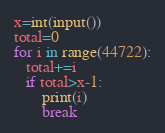<code> <loc_0><loc_0><loc_500><loc_500><_Python_>x=int(input())
total=0
for i in range(44722):
   total+=i
   if total>x-1:
       print(i)
       break
</code> 